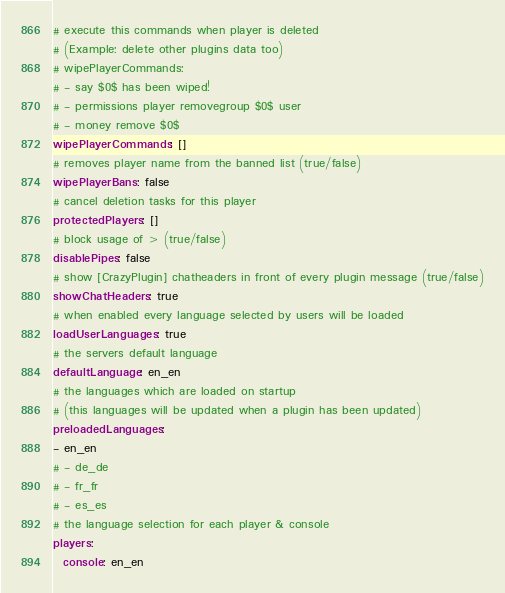<code> <loc_0><loc_0><loc_500><loc_500><_YAML_># execute this commands when player is deleted 
# (Example: delete other plugins data too)
# wipePlayerCommands:
# - say $0$ has been wiped!
# - permissions player removegroup $0$ user
# - money remove $0$
wipePlayerCommands: []
# removes player name from the banned list (true/false)
wipePlayerBans: false
# cancel deletion tasks for this player
protectedPlayers: []
# block usage of > (true/false)
disablePipes: false
# show [CrazyPlugin] chatheaders in front of every plugin message (true/false)
showChatHeaders: true
# when enabled every language selected by users will be loaded
loadUserLanguages: true
# the servers default language
defaultLanguage: en_en
# the languages which are loaded on startup 
# (this languages will be updated when a plugin has been updated)
preloadedLanguages:
- en_en
# - de_de
# - fr_fr
# - es_es
# the language selection for each player & console
players:
  console: en_en
</code> 